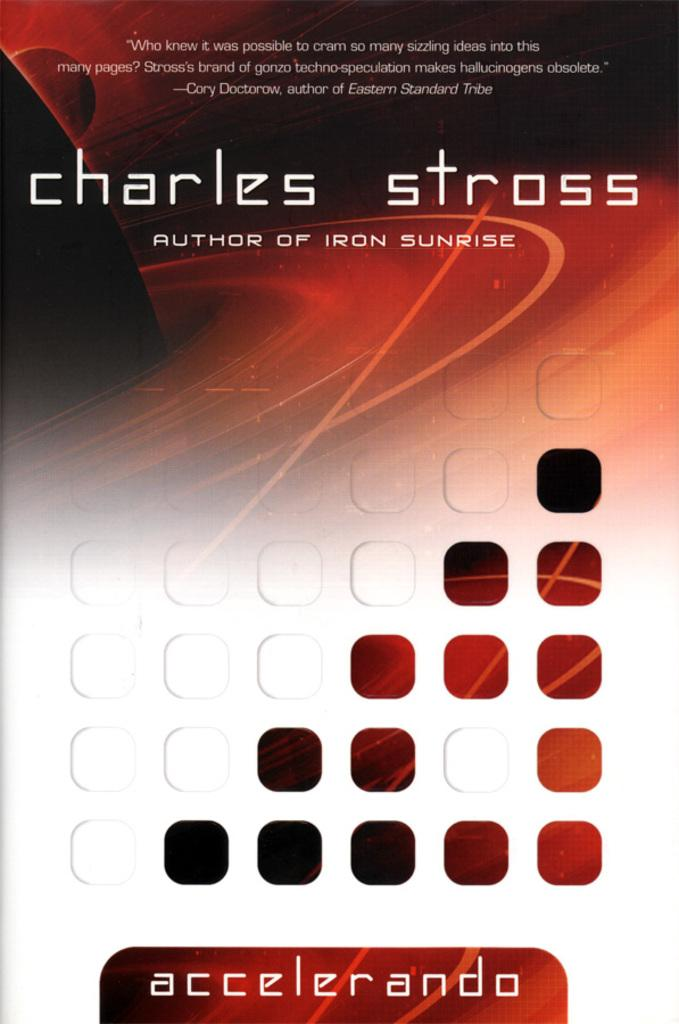<image>
Present a compact description of the photo's key features. The book cover for Accelerando by with a red planet in the artwork by Charles Stross. 